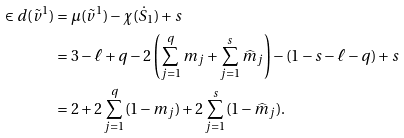Convert formula to latex. <formula><loc_0><loc_0><loc_500><loc_500>\in d ( \tilde { v } ^ { 1 } ) & = \mu ( \tilde { v } ^ { 1 } ) - \chi ( \dot { S } _ { 1 } ) + s \\ & = 3 - \ell + q - 2 \left ( \sum _ { j = 1 } ^ { q } m _ { j } + \sum _ { j = 1 } ^ { s } \widehat { m } _ { j } \right ) - ( 1 - s - \ell - q ) + s \\ & = 2 + 2 \sum _ { j = 1 } ^ { q } ( 1 - m _ { j } ) + 2 \sum _ { j = 1 } ^ { s } ( 1 - \widehat { m } _ { j } ) .</formula> 